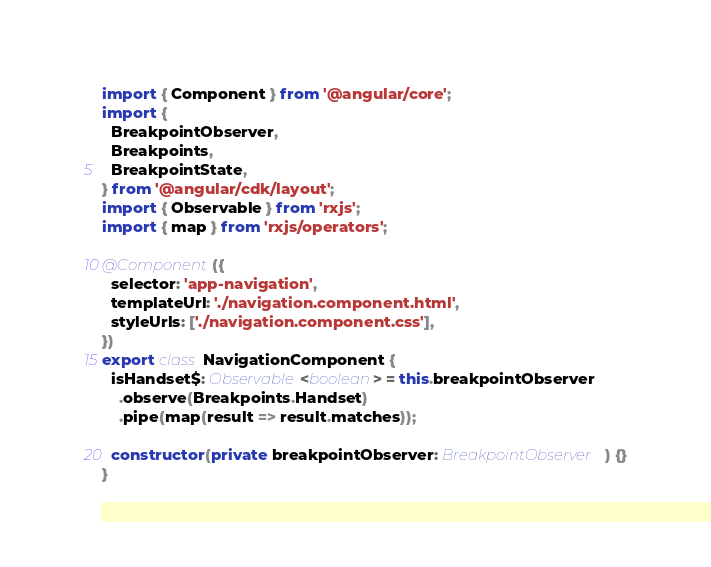<code> <loc_0><loc_0><loc_500><loc_500><_TypeScript_>import { Component } from '@angular/core';
import {
  BreakpointObserver,
  Breakpoints,
  BreakpointState,
} from '@angular/cdk/layout';
import { Observable } from 'rxjs';
import { map } from 'rxjs/operators';

@Component({
  selector: 'app-navigation',
  templateUrl: './navigation.component.html',
  styleUrls: ['./navigation.component.css'],
})
export class NavigationComponent {
  isHandset$: Observable<boolean> = this.breakpointObserver
    .observe(Breakpoints.Handset)
    .pipe(map(result => result.matches));

  constructor(private breakpointObserver: BreakpointObserver) {}
}
</code> 